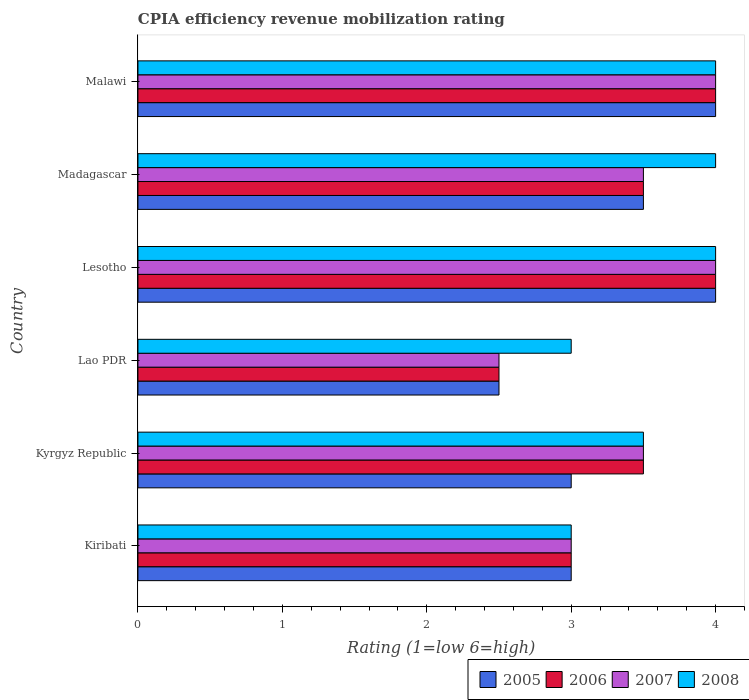How many different coloured bars are there?
Offer a very short reply. 4. How many groups of bars are there?
Give a very brief answer. 6. Are the number of bars per tick equal to the number of legend labels?
Give a very brief answer. Yes. How many bars are there on the 3rd tick from the top?
Your response must be concise. 4. What is the label of the 3rd group of bars from the top?
Offer a terse response. Lesotho. In how many cases, is the number of bars for a given country not equal to the number of legend labels?
Make the answer very short. 0. Across all countries, what is the minimum CPIA rating in 2005?
Provide a short and direct response. 2.5. In which country was the CPIA rating in 2007 maximum?
Make the answer very short. Lesotho. In which country was the CPIA rating in 2007 minimum?
Make the answer very short. Lao PDR. What is the total CPIA rating in 2007 in the graph?
Your response must be concise. 20.5. What is the average CPIA rating in 2007 per country?
Offer a terse response. 3.42. In how many countries, is the CPIA rating in 2008 greater than 0.2 ?
Make the answer very short. 6. Is the CPIA rating in 2006 in Kyrgyz Republic less than that in Madagascar?
Ensure brevity in your answer.  No. What is the difference between the highest and the lowest CPIA rating in 2007?
Keep it short and to the point. 1.5. In how many countries, is the CPIA rating in 2007 greater than the average CPIA rating in 2007 taken over all countries?
Provide a succinct answer. 4. Is it the case that in every country, the sum of the CPIA rating in 2005 and CPIA rating in 2007 is greater than the sum of CPIA rating in 2008 and CPIA rating in 2006?
Your answer should be compact. No. What does the 2nd bar from the bottom in Lesotho represents?
Your answer should be compact. 2006. How many bars are there?
Your answer should be very brief. 24. Are the values on the major ticks of X-axis written in scientific E-notation?
Provide a short and direct response. No. Where does the legend appear in the graph?
Ensure brevity in your answer.  Bottom right. How are the legend labels stacked?
Keep it short and to the point. Horizontal. What is the title of the graph?
Offer a very short reply. CPIA efficiency revenue mobilization rating. Does "1978" appear as one of the legend labels in the graph?
Offer a terse response. No. What is the label or title of the Y-axis?
Provide a succinct answer. Country. What is the Rating (1=low 6=high) of 2005 in Kiribati?
Your answer should be compact. 3. What is the Rating (1=low 6=high) in 2007 in Kiribati?
Your answer should be very brief. 3. What is the Rating (1=low 6=high) of 2005 in Kyrgyz Republic?
Your answer should be compact. 3. What is the Rating (1=low 6=high) of 2008 in Kyrgyz Republic?
Provide a short and direct response. 3.5. What is the Rating (1=low 6=high) in 2007 in Lao PDR?
Offer a very short reply. 2.5. What is the Rating (1=low 6=high) in 2008 in Lao PDR?
Keep it short and to the point. 3. What is the Rating (1=low 6=high) of 2008 in Lesotho?
Your answer should be compact. 4. What is the Rating (1=low 6=high) of 2005 in Madagascar?
Your answer should be compact. 3.5. What is the Rating (1=low 6=high) in 2007 in Madagascar?
Your answer should be compact. 3.5. What is the Rating (1=low 6=high) in 2008 in Malawi?
Your answer should be compact. 4. Across all countries, what is the maximum Rating (1=low 6=high) of 2005?
Provide a short and direct response. 4. Across all countries, what is the maximum Rating (1=low 6=high) in 2007?
Your response must be concise. 4. Across all countries, what is the minimum Rating (1=low 6=high) of 2006?
Your answer should be very brief. 2.5. Across all countries, what is the minimum Rating (1=low 6=high) in 2007?
Your answer should be very brief. 2.5. What is the total Rating (1=low 6=high) of 2006 in the graph?
Offer a very short reply. 20.5. What is the total Rating (1=low 6=high) of 2008 in the graph?
Provide a succinct answer. 21.5. What is the difference between the Rating (1=low 6=high) in 2006 in Kiribati and that in Kyrgyz Republic?
Make the answer very short. -0.5. What is the difference between the Rating (1=low 6=high) in 2007 in Kiribati and that in Kyrgyz Republic?
Your answer should be compact. -0.5. What is the difference between the Rating (1=low 6=high) in 2006 in Kiribati and that in Lao PDR?
Provide a succinct answer. 0.5. What is the difference between the Rating (1=low 6=high) of 2008 in Kiribati and that in Lesotho?
Your answer should be compact. -1. What is the difference between the Rating (1=low 6=high) of 2005 in Kiribati and that in Madagascar?
Give a very brief answer. -0.5. What is the difference between the Rating (1=low 6=high) in 2005 in Kiribati and that in Malawi?
Your response must be concise. -1. What is the difference between the Rating (1=low 6=high) in 2007 in Kiribati and that in Malawi?
Your answer should be very brief. -1. What is the difference between the Rating (1=low 6=high) of 2008 in Kyrgyz Republic and that in Lesotho?
Provide a short and direct response. -0.5. What is the difference between the Rating (1=low 6=high) of 2005 in Kyrgyz Republic and that in Malawi?
Your response must be concise. -1. What is the difference between the Rating (1=low 6=high) in 2006 in Kyrgyz Republic and that in Malawi?
Your answer should be very brief. -0.5. What is the difference between the Rating (1=low 6=high) in 2007 in Kyrgyz Republic and that in Malawi?
Offer a terse response. -0.5. What is the difference between the Rating (1=low 6=high) in 2008 in Kyrgyz Republic and that in Malawi?
Offer a terse response. -0.5. What is the difference between the Rating (1=low 6=high) in 2008 in Lao PDR and that in Lesotho?
Your response must be concise. -1. What is the difference between the Rating (1=low 6=high) of 2005 in Lao PDR and that in Madagascar?
Your response must be concise. -1. What is the difference between the Rating (1=low 6=high) of 2006 in Lao PDR and that in Madagascar?
Make the answer very short. -1. What is the difference between the Rating (1=low 6=high) of 2006 in Lao PDR and that in Malawi?
Make the answer very short. -1.5. What is the difference between the Rating (1=low 6=high) in 2008 in Lao PDR and that in Malawi?
Give a very brief answer. -1. What is the difference between the Rating (1=low 6=high) of 2008 in Lesotho and that in Madagascar?
Your response must be concise. 0. What is the difference between the Rating (1=low 6=high) of 2008 in Lesotho and that in Malawi?
Make the answer very short. 0. What is the difference between the Rating (1=low 6=high) of 2006 in Madagascar and that in Malawi?
Make the answer very short. -0.5. What is the difference between the Rating (1=low 6=high) in 2007 in Madagascar and that in Malawi?
Provide a short and direct response. -0.5. What is the difference between the Rating (1=low 6=high) of 2008 in Madagascar and that in Malawi?
Your answer should be very brief. 0. What is the difference between the Rating (1=low 6=high) in 2005 in Kiribati and the Rating (1=low 6=high) in 2007 in Kyrgyz Republic?
Offer a very short reply. -0.5. What is the difference between the Rating (1=low 6=high) in 2006 in Kiribati and the Rating (1=low 6=high) in 2007 in Kyrgyz Republic?
Provide a succinct answer. -0.5. What is the difference between the Rating (1=low 6=high) of 2005 in Kiribati and the Rating (1=low 6=high) of 2006 in Lao PDR?
Offer a very short reply. 0.5. What is the difference between the Rating (1=low 6=high) in 2005 in Kiribati and the Rating (1=low 6=high) in 2007 in Lao PDR?
Ensure brevity in your answer.  0.5. What is the difference between the Rating (1=low 6=high) in 2005 in Kiribati and the Rating (1=low 6=high) in 2008 in Lao PDR?
Ensure brevity in your answer.  0. What is the difference between the Rating (1=low 6=high) of 2006 in Kiribati and the Rating (1=low 6=high) of 2008 in Lao PDR?
Your answer should be very brief. 0. What is the difference between the Rating (1=low 6=high) in 2007 in Kiribati and the Rating (1=low 6=high) in 2008 in Lao PDR?
Keep it short and to the point. 0. What is the difference between the Rating (1=low 6=high) in 2005 in Kiribati and the Rating (1=low 6=high) in 2008 in Lesotho?
Provide a succinct answer. -1. What is the difference between the Rating (1=low 6=high) in 2006 in Kiribati and the Rating (1=low 6=high) in 2007 in Lesotho?
Your answer should be compact. -1. What is the difference between the Rating (1=low 6=high) of 2005 in Kiribati and the Rating (1=low 6=high) of 2006 in Madagascar?
Make the answer very short. -0.5. What is the difference between the Rating (1=low 6=high) in 2005 in Kiribati and the Rating (1=low 6=high) in 2007 in Madagascar?
Your answer should be very brief. -0.5. What is the difference between the Rating (1=low 6=high) in 2007 in Kiribati and the Rating (1=low 6=high) in 2008 in Madagascar?
Offer a terse response. -1. What is the difference between the Rating (1=low 6=high) of 2005 in Kiribati and the Rating (1=low 6=high) of 2006 in Malawi?
Give a very brief answer. -1. What is the difference between the Rating (1=low 6=high) of 2006 in Kiribati and the Rating (1=low 6=high) of 2007 in Malawi?
Give a very brief answer. -1. What is the difference between the Rating (1=low 6=high) in 2005 in Kyrgyz Republic and the Rating (1=low 6=high) in 2006 in Lao PDR?
Provide a short and direct response. 0.5. What is the difference between the Rating (1=low 6=high) of 2006 in Kyrgyz Republic and the Rating (1=low 6=high) of 2008 in Lao PDR?
Offer a very short reply. 0.5. What is the difference between the Rating (1=low 6=high) in 2005 in Kyrgyz Republic and the Rating (1=low 6=high) in 2006 in Lesotho?
Offer a very short reply. -1. What is the difference between the Rating (1=low 6=high) in 2005 in Kyrgyz Republic and the Rating (1=low 6=high) in 2007 in Lesotho?
Your answer should be very brief. -1. What is the difference between the Rating (1=low 6=high) of 2005 in Kyrgyz Republic and the Rating (1=low 6=high) of 2008 in Lesotho?
Your answer should be compact. -1. What is the difference between the Rating (1=low 6=high) in 2006 in Kyrgyz Republic and the Rating (1=low 6=high) in 2007 in Lesotho?
Offer a very short reply. -0.5. What is the difference between the Rating (1=low 6=high) in 2006 in Kyrgyz Republic and the Rating (1=low 6=high) in 2008 in Lesotho?
Provide a short and direct response. -0.5. What is the difference between the Rating (1=low 6=high) in 2005 in Kyrgyz Republic and the Rating (1=low 6=high) in 2006 in Madagascar?
Offer a terse response. -0.5. What is the difference between the Rating (1=low 6=high) in 2006 in Kyrgyz Republic and the Rating (1=low 6=high) in 2007 in Madagascar?
Ensure brevity in your answer.  0. What is the difference between the Rating (1=low 6=high) in 2006 in Kyrgyz Republic and the Rating (1=low 6=high) in 2008 in Madagascar?
Your answer should be compact. -0.5. What is the difference between the Rating (1=low 6=high) of 2005 in Kyrgyz Republic and the Rating (1=low 6=high) of 2006 in Malawi?
Make the answer very short. -1. What is the difference between the Rating (1=low 6=high) of 2005 in Kyrgyz Republic and the Rating (1=low 6=high) of 2007 in Malawi?
Provide a succinct answer. -1. What is the difference between the Rating (1=low 6=high) in 2006 in Kyrgyz Republic and the Rating (1=low 6=high) in 2007 in Malawi?
Offer a very short reply. -0.5. What is the difference between the Rating (1=low 6=high) in 2006 in Kyrgyz Republic and the Rating (1=low 6=high) in 2008 in Malawi?
Your answer should be compact. -0.5. What is the difference between the Rating (1=low 6=high) of 2007 in Kyrgyz Republic and the Rating (1=low 6=high) of 2008 in Malawi?
Give a very brief answer. -0.5. What is the difference between the Rating (1=low 6=high) in 2005 in Lao PDR and the Rating (1=low 6=high) in 2007 in Lesotho?
Give a very brief answer. -1.5. What is the difference between the Rating (1=low 6=high) of 2005 in Lao PDR and the Rating (1=low 6=high) of 2008 in Lesotho?
Your answer should be very brief. -1.5. What is the difference between the Rating (1=low 6=high) in 2006 in Lao PDR and the Rating (1=low 6=high) in 2008 in Lesotho?
Ensure brevity in your answer.  -1.5. What is the difference between the Rating (1=low 6=high) in 2007 in Lao PDR and the Rating (1=low 6=high) in 2008 in Lesotho?
Give a very brief answer. -1.5. What is the difference between the Rating (1=low 6=high) in 2005 in Lao PDR and the Rating (1=low 6=high) in 2007 in Madagascar?
Ensure brevity in your answer.  -1. What is the difference between the Rating (1=low 6=high) of 2005 in Lao PDR and the Rating (1=low 6=high) of 2008 in Madagascar?
Keep it short and to the point. -1.5. What is the difference between the Rating (1=low 6=high) in 2006 in Lao PDR and the Rating (1=low 6=high) in 2007 in Madagascar?
Offer a terse response. -1. What is the difference between the Rating (1=low 6=high) in 2007 in Lao PDR and the Rating (1=low 6=high) in 2008 in Madagascar?
Make the answer very short. -1.5. What is the difference between the Rating (1=low 6=high) in 2006 in Lao PDR and the Rating (1=low 6=high) in 2007 in Malawi?
Your answer should be very brief. -1.5. What is the difference between the Rating (1=low 6=high) of 2007 in Lao PDR and the Rating (1=low 6=high) of 2008 in Malawi?
Your answer should be very brief. -1.5. What is the difference between the Rating (1=low 6=high) in 2005 in Lesotho and the Rating (1=low 6=high) in 2006 in Madagascar?
Make the answer very short. 0.5. What is the difference between the Rating (1=low 6=high) in 2005 in Lesotho and the Rating (1=low 6=high) in 2007 in Madagascar?
Provide a short and direct response. 0.5. What is the difference between the Rating (1=low 6=high) of 2005 in Lesotho and the Rating (1=low 6=high) of 2008 in Madagascar?
Your answer should be compact. 0. What is the difference between the Rating (1=low 6=high) of 2006 in Lesotho and the Rating (1=low 6=high) of 2007 in Madagascar?
Offer a terse response. 0.5. What is the difference between the Rating (1=low 6=high) of 2007 in Lesotho and the Rating (1=low 6=high) of 2008 in Madagascar?
Offer a terse response. 0. What is the difference between the Rating (1=low 6=high) of 2006 in Lesotho and the Rating (1=low 6=high) of 2007 in Malawi?
Provide a succinct answer. 0. What is the difference between the Rating (1=low 6=high) of 2006 in Lesotho and the Rating (1=low 6=high) of 2008 in Malawi?
Offer a very short reply. 0. What is the difference between the Rating (1=low 6=high) of 2007 in Lesotho and the Rating (1=low 6=high) of 2008 in Malawi?
Make the answer very short. 0. What is the difference between the Rating (1=low 6=high) of 2005 in Madagascar and the Rating (1=low 6=high) of 2007 in Malawi?
Your response must be concise. -0.5. What is the difference between the Rating (1=low 6=high) of 2005 in Madagascar and the Rating (1=low 6=high) of 2008 in Malawi?
Make the answer very short. -0.5. What is the difference between the Rating (1=low 6=high) of 2006 in Madagascar and the Rating (1=low 6=high) of 2007 in Malawi?
Provide a short and direct response. -0.5. What is the average Rating (1=low 6=high) of 2005 per country?
Your answer should be very brief. 3.33. What is the average Rating (1=low 6=high) of 2006 per country?
Your response must be concise. 3.42. What is the average Rating (1=low 6=high) in 2007 per country?
Make the answer very short. 3.42. What is the average Rating (1=low 6=high) of 2008 per country?
Provide a short and direct response. 3.58. What is the difference between the Rating (1=low 6=high) in 2005 and Rating (1=low 6=high) in 2006 in Kiribati?
Ensure brevity in your answer.  0. What is the difference between the Rating (1=low 6=high) of 2005 and Rating (1=low 6=high) of 2006 in Kyrgyz Republic?
Keep it short and to the point. -0.5. What is the difference between the Rating (1=low 6=high) in 2005 and Rating (1=low 6=high) in 2007 in Kyrgyz Republic?
Give a very brief answer. -0.5. What is the difference between the Rating (1=low 6=high) in 2005 and Rating (1=low 6=high) in 2008 in Kyrgyz Republic?
Give a very brief answer. -0.5. What is the difference between the Rating (1=low 6=high) of 2006 and Rating (1=low 6=high) of 2007 in Kyrgyz Republic?
Offer a terse response. 0. What is the difference between the Rating (1=low 6=high) in 2006 and Rating (1=low 6=high) in 2008 in Kyrgyz Republic?
Offer a terse response. 0. What is the difference between the Rating (1=low 6=high) of 2005 and Rating (1=low 6=high) of 2006 in Lao PDR?
Your response must be concise. 0. What is the difference between the Rating (1=low 6=high) in 2005 and Rating (1=low 6=high) in 2007 in Lao PDR?
Keep it short and to the point. 0. What is the difference between the Rating (1=low 6=high) in 2006 and Rating (1=low 6=high) in 2007 in Lao PDR?
Your response must be concise. 0. What is the difference between the Rating (1=low 6=high) of 2006 and Rating (1=low 6=high) of 2008 in Lao PDR?
Your answer should be very brief. -0.5. What is the difference between the Rating (1=low 6=high) of 2005 and Rating (1=low 6=high) of 2008 in Lesotho?
Offer a very short reply. 0. What is the difference between the Rating (1=low 6=high) in 2006 and Rating (1=low 6=high) in 2008 in Madagascar?
Make the answer very short. -0.5. What is the difference between the Rating (1=low 6=high) of 2007 and Rating (1=low 6=high) of 2008 in Madagascar?
Your response must be concise. -0.5. What is the difference between the Rating (1=low 6=high) in 2005 and Rating (1=low 6=high) in 2007 in Malawi?
Give a very brief answer. 0. What is the difference between the Rating (1=low 6=high) in 2006 and Rating (1=low 6=high) in 2008 in Malawi?
Offer a very short reply. 0. What is the ratio of the Rating (1=low 6=high) in 2005 in Kiribati to that in Kyrgyz Republic?
Give a very brief answer. 1. What is the ratio of the Rating (1=low 6=high) in 2006 in Kiribati to that in Kyrgyz Republic?
Your response must be concise. 0.86. What is the ratio of the Rating (1=low 6=high) of 2007 in Kiribati to that in Kyrgyz Republic?
Your response must be concise. 0.86. What is the ratio of the Rating (1=low 6=high) of 2007 in Kiribati to that in Lao PDR?
Your answer should be compact. 1.2. What is the ratio of the Rating (1=low 6=high) of 2006 in Kiribati to that in Lesotho?
Ensure brevity in your answer.  0.75. What is the ratio of the Rating (1=low 6=high) in 2008 in Kiribati to that in Lesotho?
Your answer should be compact. 0.75. What is the ratio of the Rating (1=low 6=high) in 2005 in Kiribati to that in Madagascar?
Your answer should be compact. 0.86. What is the ratio of the Rating (1=low 6=high) in 2006 in Kiribati to that in Madagascar?
Ensure brevity in your answer.  0.86. What is the ratio of the Rating (1=low 6=high) in 2007 in Kiribati to that in Madagascar?
Give a very brief answer. 0.86. What is the ratio of the Rating (1=low 6=high) of 2008 in Kiribati to that in Madagascar?
Your answer should be very brief. 0.75. What is the ratio of the Rating (1=low 6=high) in 2006 in Kiribati to that in Malawi?
Your answer should be compact. 0.75. What is the ratio of the Rating (1=low 6=high) of 2008 in Kiribati to that in Malawi?
Provide a succinct answer. 0.75. What is the ratio of the Rating (1=low 6=high) of 2005 in Kyrgyz Republic to that in Lao PDR?
Provide a short and direct response. 1.2. What is the ratio of the Rating (1=low 6=high) in 2007 in Kyrgyz Republic to that in Lao PDR?
Ensure brevity in your answer.  1.4. What is the ratio of the Rating (1=low 6=high) in 2006 in Kyrgyz Republic to that in Lesotho?
Make the answer very short. 0.88. What is the ratio of the Rating (1=low 6=high) in 2005 in Kyrgyz Republic to that in Madagascar?
Give a very brief answer. 0.86. What is the ratio of the Rating (1=low 6=high) in 2006 in Kyrgyz Republic to that in Madagascar?
Your answer should be compact. 1. What is the ratio of the Rating (1=low 6=high) of 2008 in Kyrgyz Republic to that in Madagascar?
Provide a succinct answer. 0.88. What is the ratio of the Rating (1=low 6=high) of 2005 in Lao PDR to that in Lesotho?
Make the answer very short. 0.62. What is the ratio of the Rating (1=low 6=high) in 2007 in Lao PDR to that in Lesotho?
Your answer should be very brief. 0.62. What is the ratio of the Rating (1=low 6=high) in 2008 in Lao PDR to that in Lesotho?
Make the answer very short. 0.75. What is the ratio of the Rating (1=low 6=high) of 2005 in Lao PDR to that in Madagascar?
Offer a terse response. 0.71. What is the ratio of the Rating (1=low 6=high) in 2006 in Lao PDR to that in Madagascar?
Offer a very short reply. 0.71. What is the ratio of the Rating (1=low 6=high) in 2007 in Lao PDR to that in Madagascar?
Give a very brief answer. 0.71. What is the ratio of the Rating (1=low 6=high) in 2008 in Lao PDR to that in Madagascar?
Ensure brevity in your answer.  0.75. What is the ratio of the Rating (1=low 6=high) of 2006 in Lesotho to that in Madagascar?
Provide a short and direct response. 1.14. What is the ratio of the Rating (1=low 6=high) of 2008 in Lesotho to that in Madagascar?
Ensure brevity in your answer.  1. What is the ratio of the Rating (1=low 6=high) in 2006 in Madagascar to that in Malawi?
Ensure brevity in your answer.  0.88. What is the difference between the highest and the second highest Rating (1=low 6=high) in 2005?
Your response must be concise. 0. What is the difference between the highest and the second highest Rating (1=low 6=high) in 2006?
Your response must be concise. 0. What is the difference between the highest and the second highest Rating (1=low 6=high) of 2007?
Give a very brief answer. 0. What is the difference between the highest and the lowest Rating (1=low 6=high) in 2005?
Give a very brief answer. 1.5. What is the difference between the highest and the lowest Rating (1=low 6=high) of 2007?
Ensure brevity in your answer.  1.5. What is the difference between the highest and the lowest Rating (1=low 6=high) in 2008?
Provide a succinct answer. 1. 